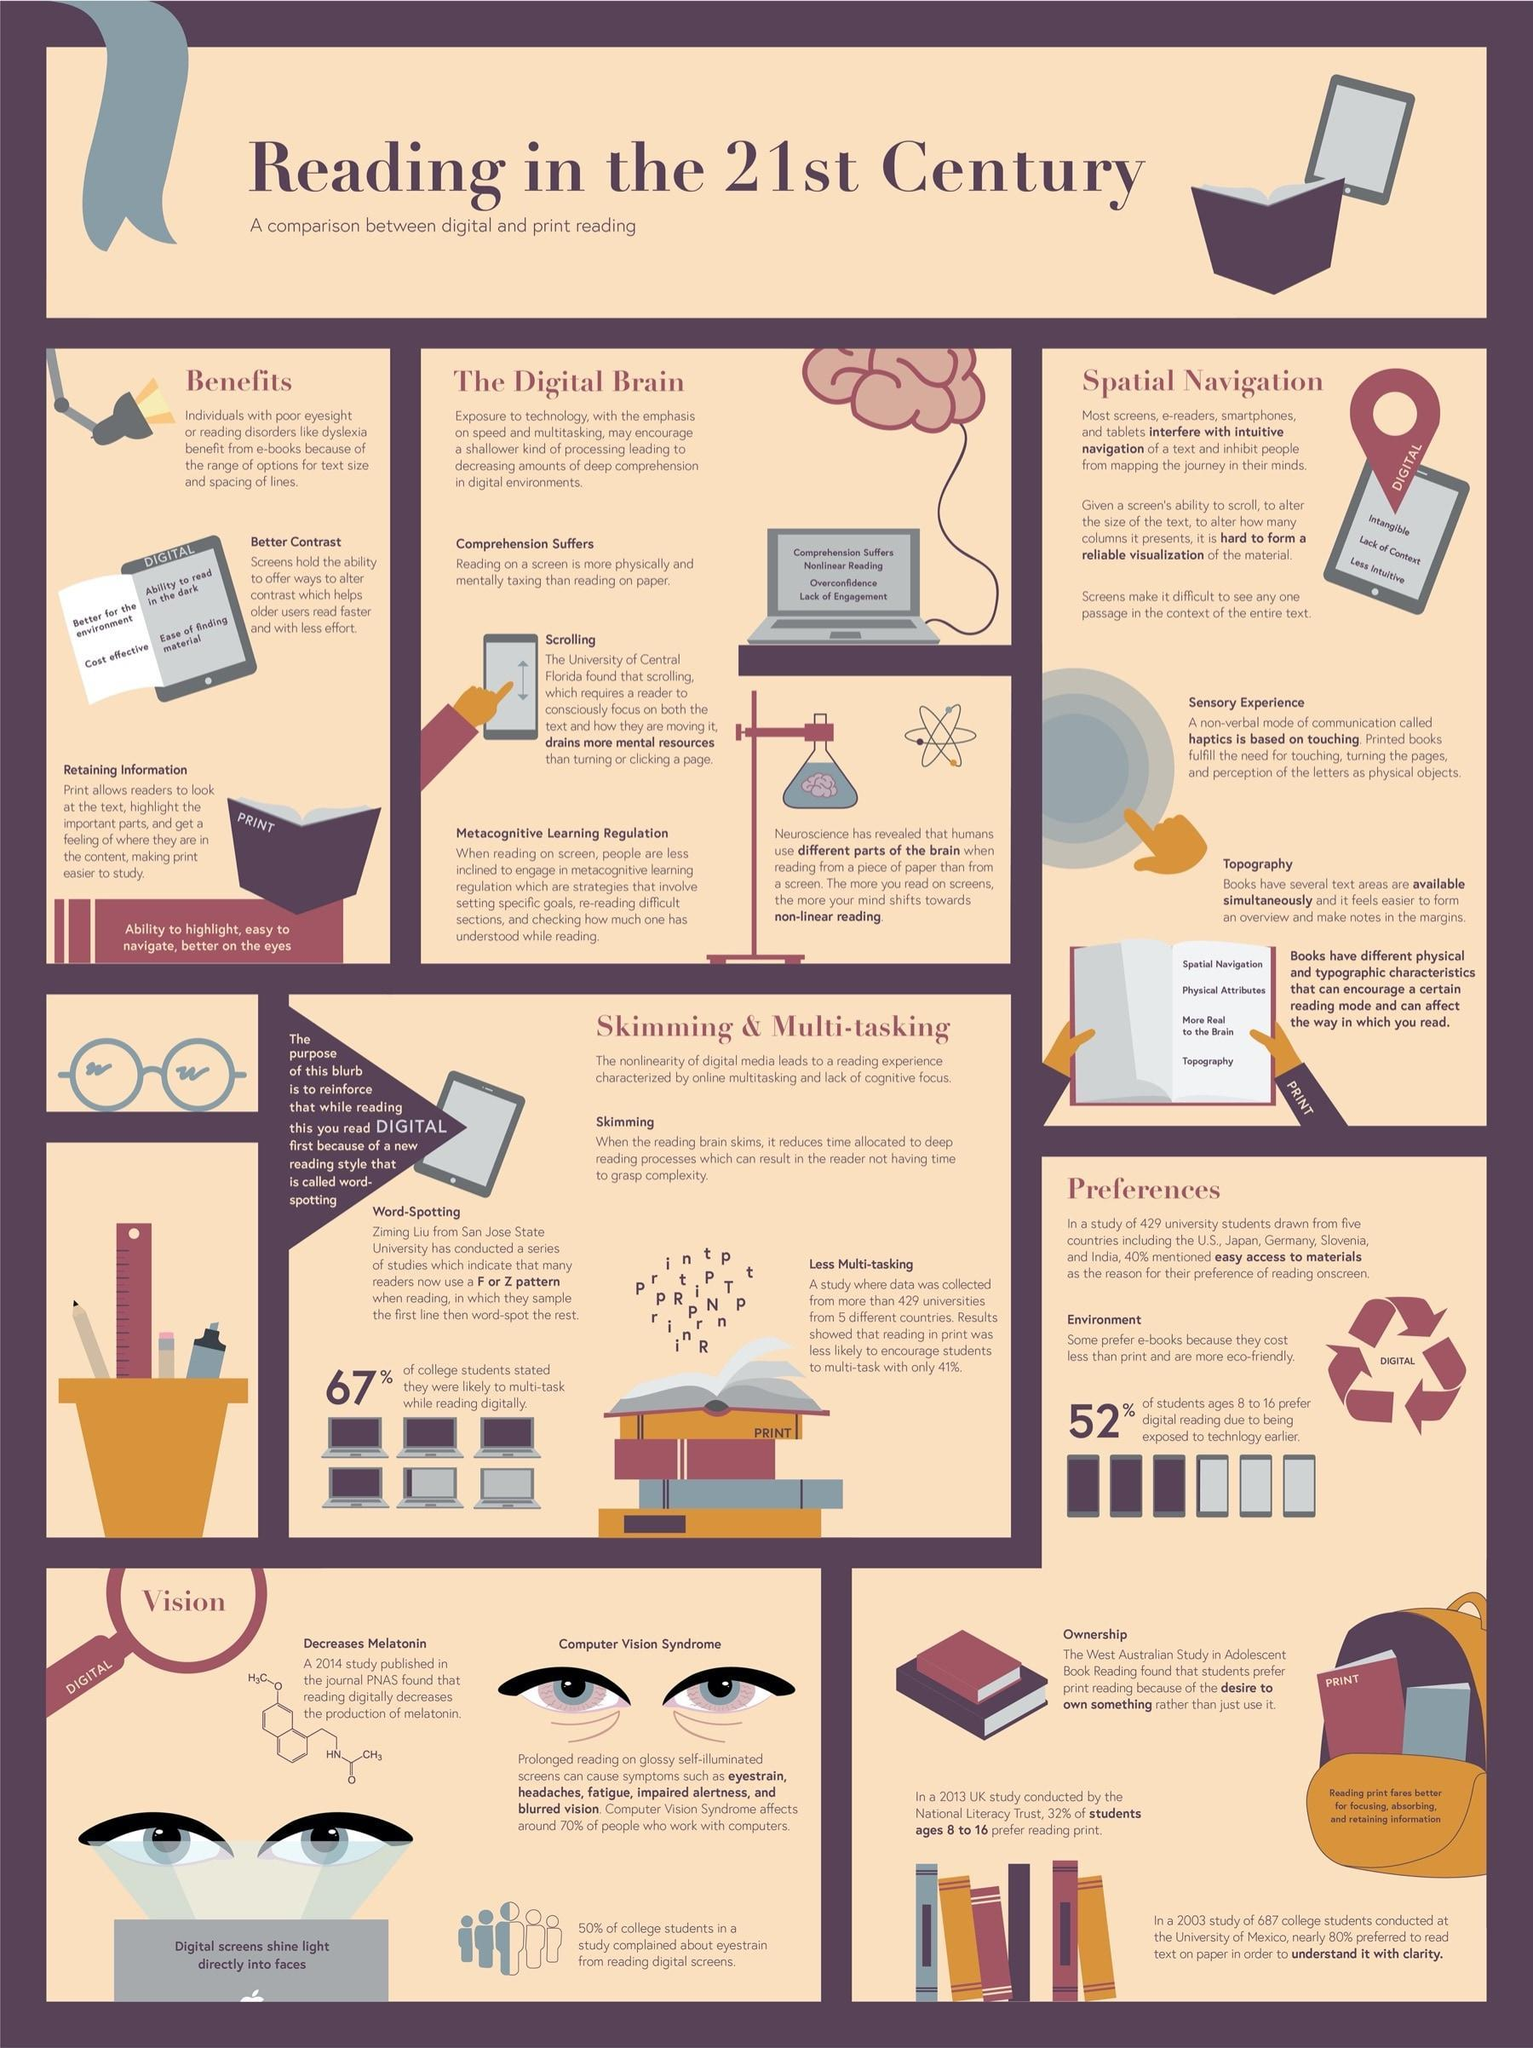With which format there is lesser chance for multi-tasking?
Answer the question with a short phrase. print Which format provides more better sensory experience? print Which media is preferred for being eco-friendly? digital Which format is better for the eyes? print Which format is more suitable for readers to retain information? print Which reading format helps to alter contrast ? digital 